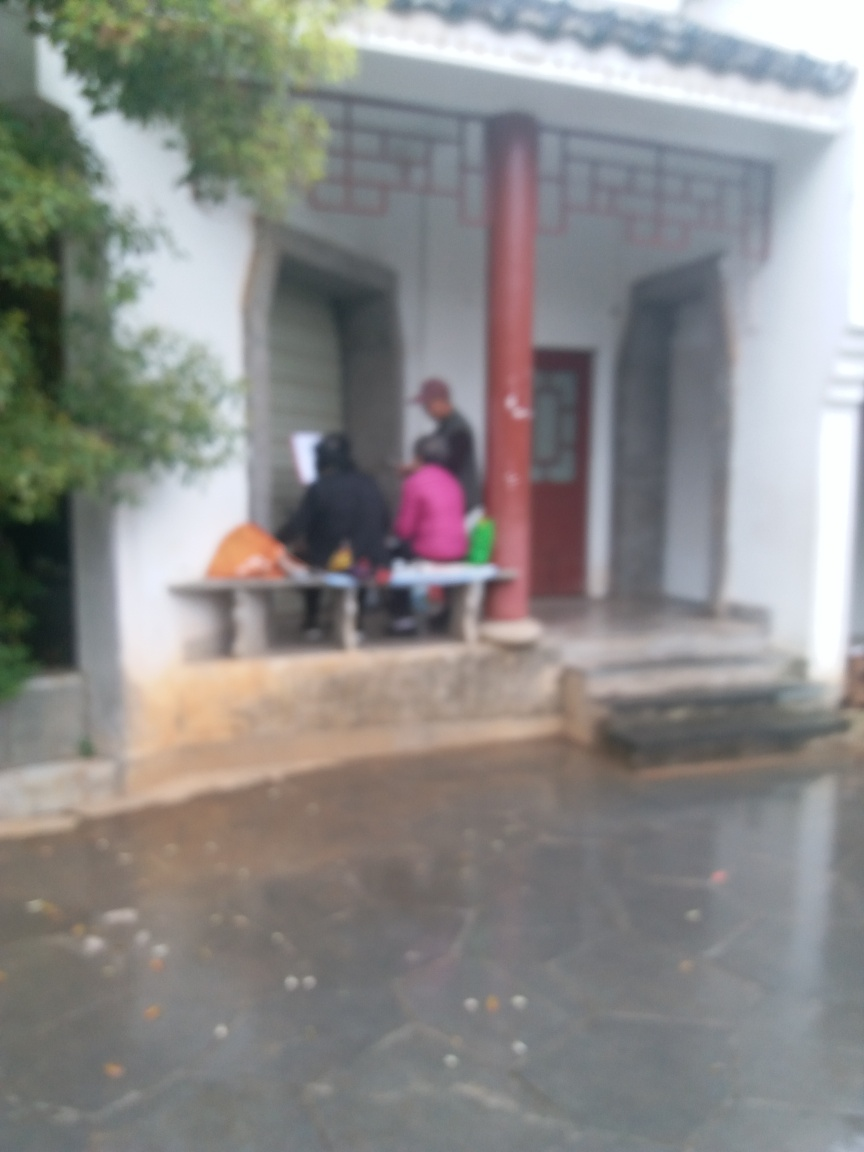Imagine this image in focus. What do you think we would see in a clearer version? If the image were in focus, we might see detailed architectural features such as the door frame, roof tiles, and windows with traditional designs. The people present might have distinguishable clothing styles and expressions, contributing to the scene's narrative. 